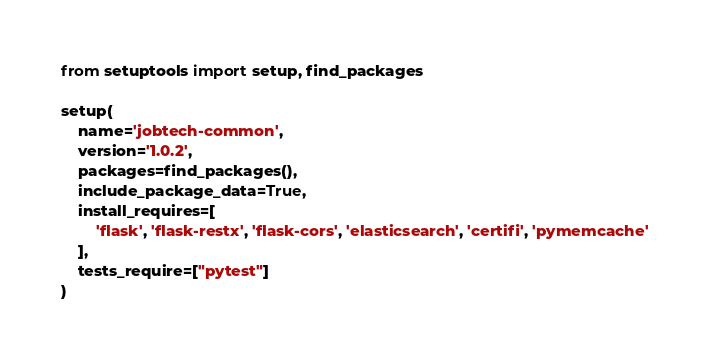Convert code to text. <code><loc_0><loc_0><loc_500><loc_500><_Python_>from setuptools import setup, find_packages

setup(
    name='jobtech-common',
    version='1.0.2',
    packages=find_packages(),
    include_package_data=True,
    install_requires=[
        'flask', 'flask-restx', 'flask-cors', 'elasticsearch', 'certifi', 'pymemcache'
    ],
    tests_require=["pytest"]
)
</code> 